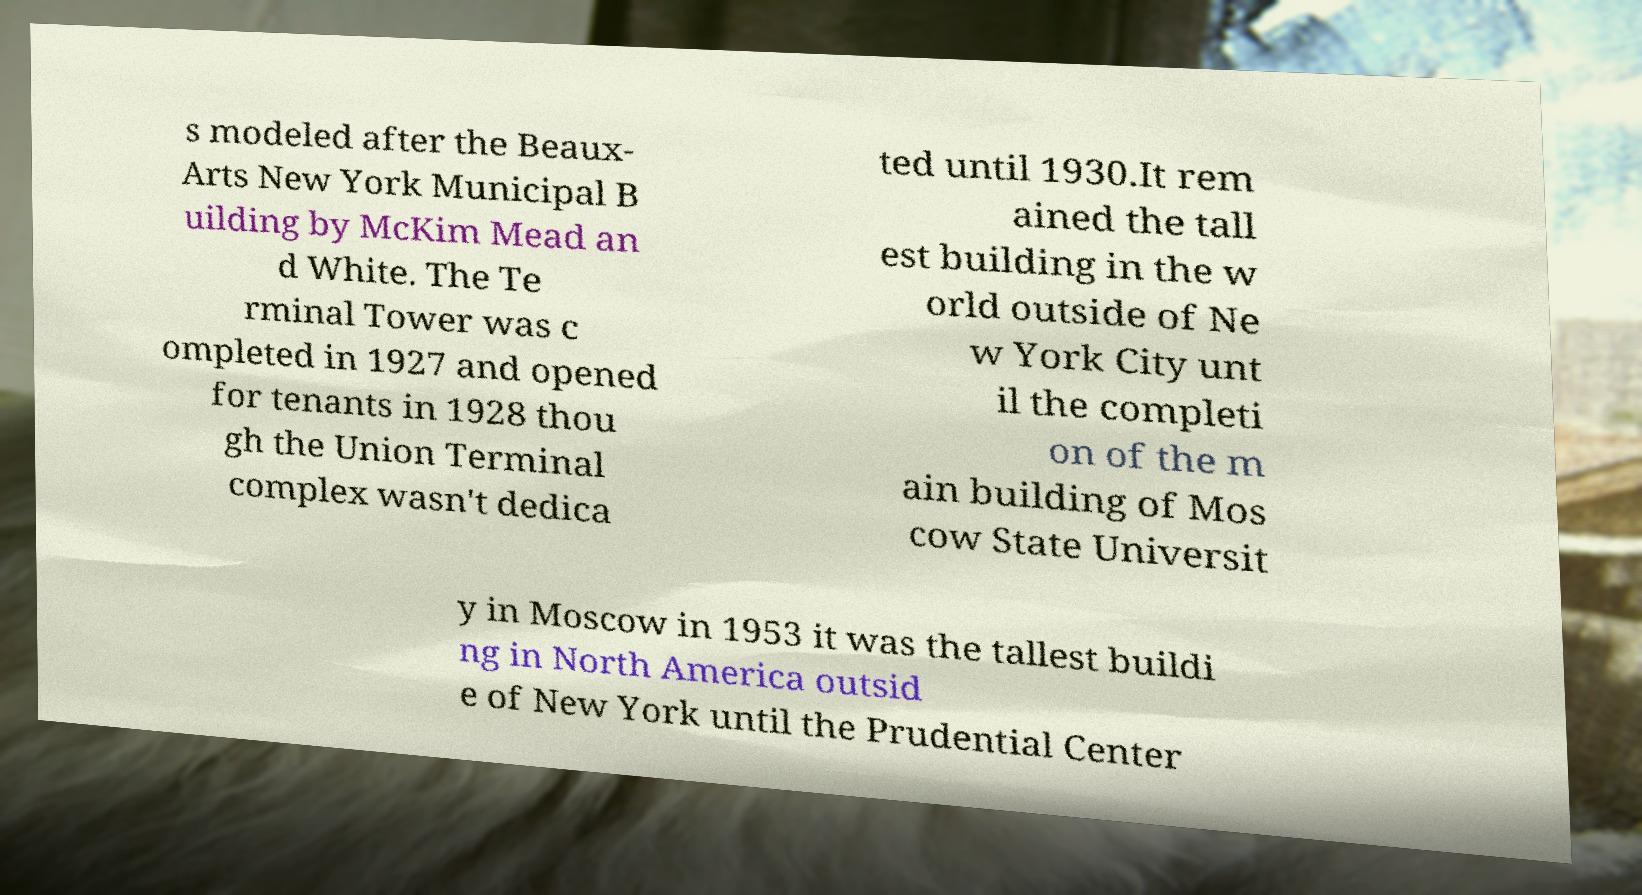There's text embedded in this image that I need extracted. Can you transcribe it verbatim? s modeled after the Beaux- Arts New York Municipal B uilding by McKim Mead an d White. The Te rminal Tower was c ompleted in 1927 and opened for tenants in 1928 thou gh the Union Terminal complex wasn't dedica ted until 1930.It rem ained the tall est building in the w orld outside of Ne w York City unt il the completi on of the m ain building of Mos cow State Universit y in Moscow in 1953 it was the tallest buildi ng in North America outsid e of New York until the Prudential Center 